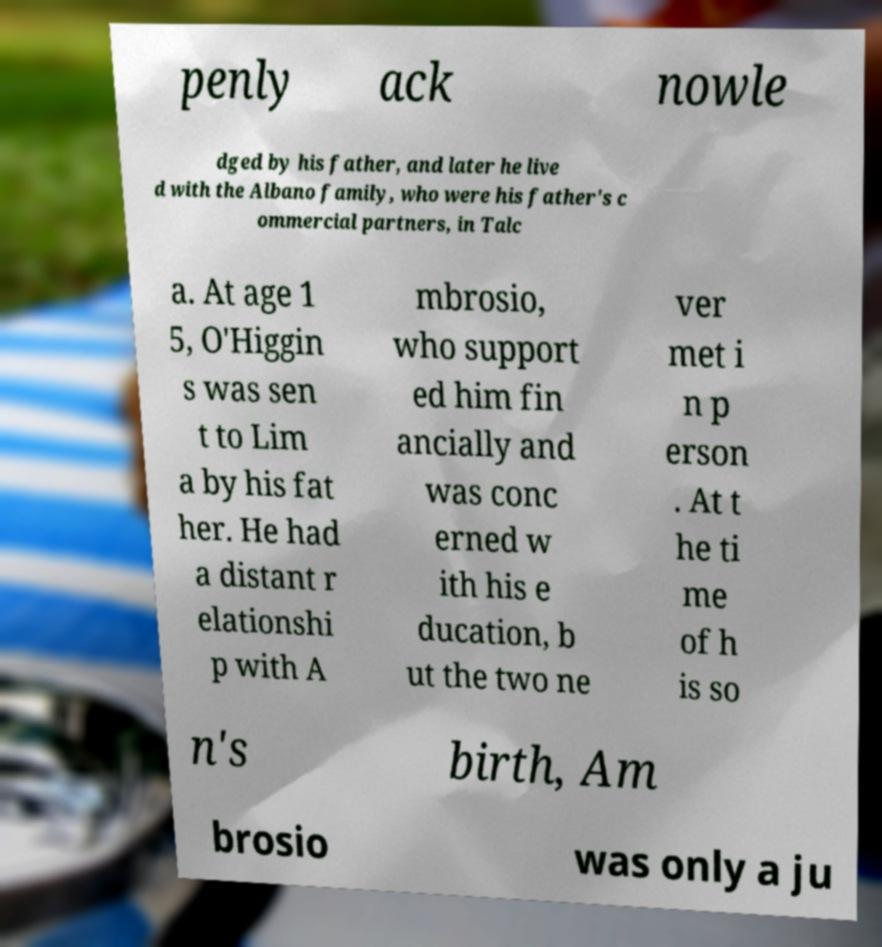There's text embedded in this image that I need extracted. Can you transcribe it verbatim? penly ack nowle dged by his father, and later he live d with the Albano family, who were his father's c ommercial partners, in Talc a. At age 1 5, O'Higgin s was sen t to Lim a by his fat her. He had a distant r elationshi p with A mbrosio, who support ed him fin ancially and was conc erned w ith his e ducation, b ut the two ne ver met i n p erson . At t he ti me of h is so n's birth, Am brosio was only a ju 